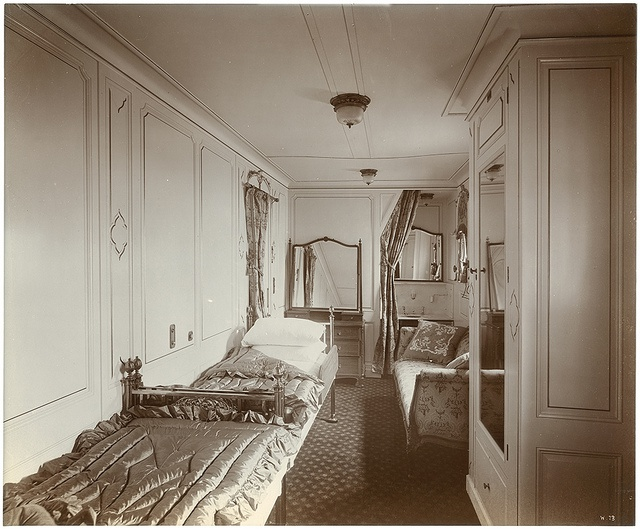Describe the objects in this image and their specific colors. I can see bed in white, gray, beige, and darkgray tones, bed in white, lightgray, darkgray, gray, and black tones, and couch in white, gray, maroon, and darkgray tones in this image. 